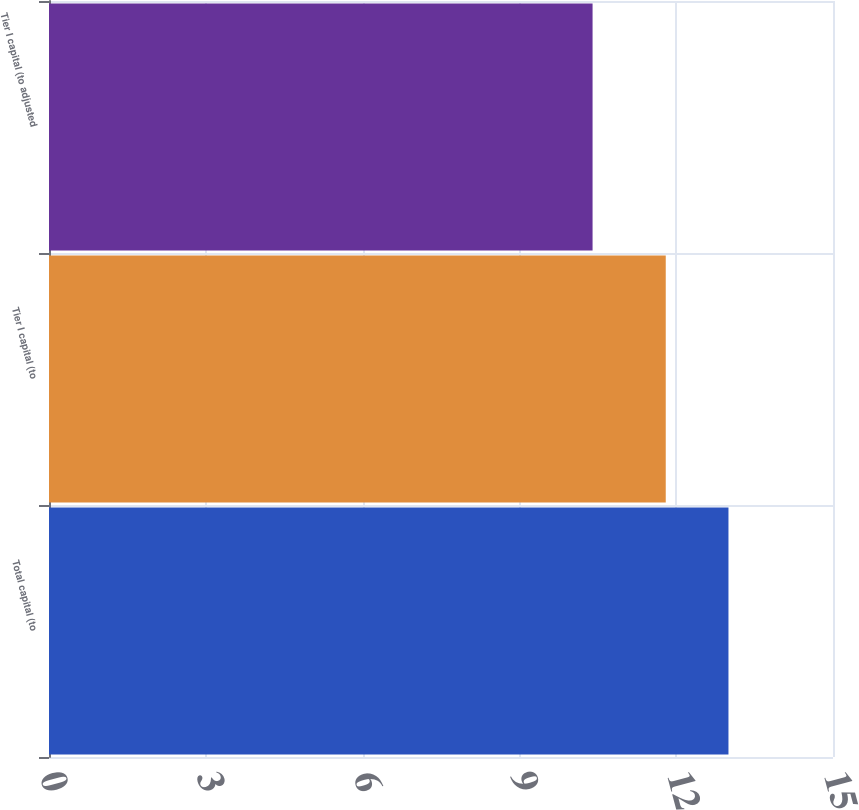Convert chart to OTSL. <chart><loc_0><loc_0><loc_500><loc_500><bar_chart><fcel>Total capital (to<fcel>Tier I capital (to<fcel>Tier I capital (to adjusted<nl><fcel>13<fcel>11.8<fcel>10.4<nl></chart> 